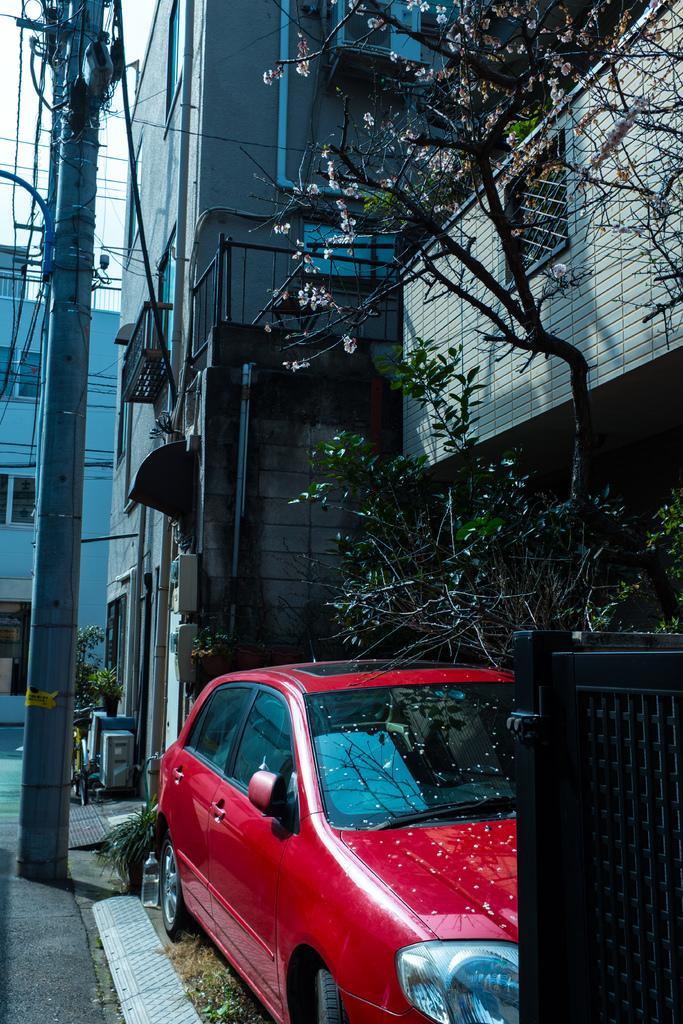How would you summarize this image in a sentence or two? In this image, we can see buildings. There is a car beside the tree. There is a gate in the bottom right of the image. There is a pole on the left side of the image. 